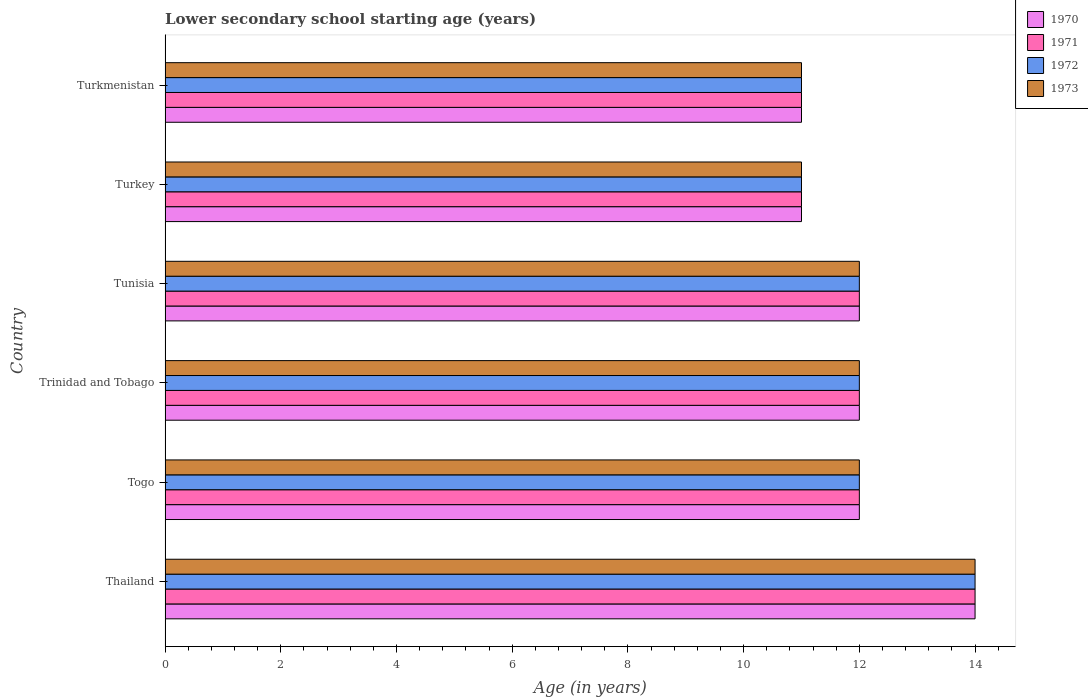How many different coloured bars are there?
Your answer should be compact. 4. Are the number of bars per tick equal to the number of legend labels?
Keep it short and to the point. Yes. Are the number of bars on each tick of the Y-axis equal?
Give a very brief answer. Yes. How many bars are there on the 6th tick from the top?
Give a very brief answer. 4. What is the label of the 6th group of bars from the top?
Keep it short and to the point. Thailand. In which country was the lower secondary school starting age of children in 1973 maximum?
Provide a short and direct response. Thailand. In which country was the lower secondary school starting age of children in 1972 minimum?
Your answer should be compact. Turkey. What is the average lower secondary school starting age of children in 1971 per country?
Your response must be concise. 12. What is the difference between the lower secondary school starting age of children in 1970 and lower secondary school starting age of children in 1973 in Turkey?
Provide a short and direct response. 0. In how many countries, is the lower secondary school starting age of children in 1970 greater than 8.4 years?
Provide a succinct answer. 6. What is the ratio of the lower secondary school starting age of children in 1973 in Thailand to that in Trinidad and Tobago?
Give a very brief answer. 1.17. What is the difference between the highest and the lowest lower secondary school starting age of children in 1970?
Keep it short and to the point. 3. Is the sum of the lower secondary school starting age of children in 1972 in Trinidad and Tobago and Tunisia greater than the maximum lower secondary school starting age of children in 1971 across all countries?
Give a very brief answer. Yes. Is it the case that in every country, the sum of the lower secondary school starting age of children in 1972 and lower secondary school starting age of children in 1970 is greater than the sum of lower secondary school starting age of children in 1971 and lower secondary school starting age of children in 1973?
Offer a very short reply. No. How many countries are there in the graph?
Make the answer very short. 6. Are the values on the major ticks of X-axis written in scientific E-notation?
Give a very brief answer. No. Where does the legend appear in the graph?
Give a very brief answer. Top right. What is the title of the graph?
Your answer should be compact. Lower secondary school starting age (years). Does "1987" appear as one of the legend labels in the graph?
Offer a very short reply. No. What is the label or title of the X-axis?
Make the answer very short. Age (in years). What is the label or title of the Y-axis?
Provide a short and direct response. Country. What is the Age (in years) of 1971 in Thailand?
Provide a short and direct response. 14. What is the Age (in years) in 1972 in Thailand?
Your response must be concise. 14. What is the Age (in years) in 1971 in Togo?
Provide a succinct answer. 12. What is the Age (in years) in 1971 in Trinidad and Tobago?
Provide a short and direct response. 12. What is the Age (in years) of 1972 in Trinidad and Tobago?
Keep it short and to the point. 12. What is the Age (in years) of 1970 in Tunisia?
Your answer should be compact. 12. What is the Age (in years) in 1971 in Tunisia?
Keep it short and to the point. 12. What is the Age (in years) of 1972 in Tunisia?
Make the answer very short. 12. What is the Age (in years) in 1971 in Turkey?
Ensure brevity in your answer.  11. What is the Age (in years) of 1972 in Turkey?
Give a very brief answer. 11. What is the Age (in years) in 1973 in Turkey?
Give a very brief answer. 11. What is the Age (in years) of 1970 in Turkmenistan?
Keep it short and to the point. 11. What is the Age (in years) of 1971 in Turkmenistan?
Your answer should be very brief. 11. What is the Age (in years) of 1973 in Turkmenistan?
Your answer should be very brief. 11. Across all countries, what is the maximum Age (in years) in 1970?
Make the answer very short. 14. Across all countries, what is the maximum Age (in years) in 1972?
Give a very brief answer. 14. Across all countries, what is the minimum Age (in years) of 1970?
Provide a succinct answer. 11. Across all countries, what is the minimum Age (in years) in 1971?
Make the answer very short. 11. Across all countries, what is the minimum Age (in years) in 1972?
Give a very brief answer. 11. Across all countries, what is the minimum Age (in years) of 1973?
Offer a terse response. 11. What is the total Age (in years) of 1970 in the graph?
Provide a short and direct response. 72. What is the total Age (in years) in 1973 in the graph?
Provide a succinct answer. 72. What is the difference between the Age (in years) of 1970 in Thailand and that in Togo?
Your response must be concise. 2. What is the difference between the Age (in years) in 1971 in Thailand and that in Togo?
Provide a short and direct response. 2. What is the difference between the Age (in years) in 1971 in Thailand and that in Tunisia?
Ensure brevity in your answer.  2. What is the difference between the Age (in years) of 1972 in Thailand and that in Tunisia?
Offer a terse response. 2. What is the difference between the Age (in years) of 1970 in Thailand and that in Turkey?
Keep it short and to the point. 3. What is the difference between the Age (in years) of 1972 in Thailand and that in Turkey?
Provide a short and direct response. 3. What is the difference between the Age (in years) in 1970 in Thailand and that in Turkmenistan?
Provide a succinct answer. 3. What is the difference between the Age (in years) in 1972 in Thailand and that in Turkmenistan?
Your answer should be compact. 3. What is the difference between the Age (in years) of 1970 in Togo and that in Tunisia?
Offer a very short reply. 0. What is the difference between the Age (in years) of 1971 in Togo and that in Tunisia?
Your answer should be very brief. 0. What is the difference between the Age (in years) of 1972 in Togo and that in Turkey?
Keep it short and to the point. 1. What is the difference between the Age (in years) of 1973 in Togo and that in Turkey?
Offer a very short reply. 1. What is the difference between the Age (in years) of 1972 in Togo and that in Turkmenistan?
Your answer should be compact. 1. What is the difference between the Age (in years) of 1970 in Trinidad and Tobago and that in Tunisia?
Your answer should be very brief. 0. What is the difference between the Age (in years) of 1971 in Trinidad and Tobago and that in Tunisia?
Ensure brevity in your answer.  0. What is the difference between the Age (in years) in 1973 in Trinidad and Tobago and that in Tunisia?
Ensure brevity in your answer.  0. What is the difference between the Age (in years) of 1972 in Trinidad and Tobago and that in Turkey?
Keep it short and to the point. 1. What is the difference between the Age (in years) of 1973 in Trinidad and Tobago and that in Turkey?
Make the answer very short. 1. What is the difference between the Age (in years) of 1970 in Trinidad and Tobago and that in Turkmenistan?
Provide a succinct answer. 1. What is the difference between the Age (in years) in 1973 in Trinidad and Tobago and that in Turkmenistan?
Keep it short and to the point. 1. What is the difference between the Age (in years) in 1970 in Tunisia and that in Turkey?
Offer a terse response. 1. What is the difference between the Age (in years) of 1972 in Tunisia and that in Turkey?
Give a very brief answer. 1. What is the difference between the Age (in years) of 1971 in Tunisia and that in Turkmenistan?
Your answer should be very brief. 1. What is the difference between the Age (in years) in 1973 in Tunisia and that in Turkmenistan?
Keep it short and to the point. 1. What is the difference between the Age (in years) in 1970 in Turkey and that in Turkmenistan?
Your answer should be very brief. 0. What is the difference between the Age (in years) in 1972 in Turkey and that in Turkmenistan?
Your answer should be compact. 0. What is the difference between the Age (in years) in 1971 in Thailand and the Age (in years) in 1972 in Togo?
Make the answer very short. 2. What is the difference between the Age (in years) of 1971 in Thailand and the Age (in years) of 1973 in Togo?
Give a very brief answer. 2. What is the difference between the Age (in years) in 1971 in Thailand and the Age (in years) in 1973 in Trinidad and Tobago?
Offer a very short reply. 2. What is the difference between the Age (in years) of 1970 in Thailand and the Age (in years) of 1972 in Tunisia?
Provide a short and direct response. 2. What is the difference between the Age (in years) in 1971 in Thailand and the Age (in years) in 1973 in Tunisia?
Your answer should be very brief. 2. What is the difference between the Age (in years) of 1972 in Thailand and the Age (in years) of 1973 in Tunisia?
Provide a short and direct response. 2. What is the difference between the Age (in years) in 1970 in Thailand and the Age (in years) in 1972 in Turkey?
Ensure brevity in your answer.  3. What is the difference between the Age (in years) of 1970 in Thailand and the Age (in years) of 1973 in Turkey?
Give a very brief answer. 3. What is the difference between the Age (in years) of 1971 in Thailand and the Age (in years) of 1972 in Turkey?
Make the answer very short. 3. What is the difference between the Age (in years) of 1970 in Thailand and the Age (in years) of 1971 in Turkmenistan?
Your answer should be very brief. 3. What is the difference between the Age (in years) in 1971 in Thailand and the Age (in years) in 1972 in Turkmenistan?
Provide a succinct answer. 3. What is the difference between the Age (in years) in 1971 in Thailand and the Age (in years) in 1973 in Turkmenistan?
Provide a succinct answer. 3. What is the difference between the Age (in years) of 1972 in Thailand and the Age (in years) of 1973 in Turkmenistan?
Your answer should be compact. 3. What is the difference between the Age (in years) in 1970 in Togo and the Age (in years) in 1972 in Trinidad and Tobago?
Offer a terse response. 0. What is the difference between the Age (in years) in 1970 in Togo and the Age (in years) in 1973 in Trinidad and Tobago?
Ensure brevity in your answer.  0. What is the difference between the Age (in years) of 1971 in Togo and the Age (in years) of 1973 in Trinidad and Tobago?
Your answer should be very brief. 0. What is the difference between the Age (in years) of 1972 in Togo and the Age (in years) of 1973 in Trinidad and Tobago?
Your answer should be compact. 0. What is the difference between the Age (in years) in 1970 in Togo and the Age (in years) in 1971 in Tunisia?
Keep it short and to the point. 0. What is the difference between the Age (in years) in 1970 in Togo and the Age (in years) in 1972 in Tunisia?
Provide a succinct answer. 0. What is the difference between the Age (in years) of 1970 in Togo and the Age (in years) of 1973 in Tunisia?
Keep it short and to the point. 0. What is the difference between the Age (in years) of 1970 in Togo and the Age (in years) of 1971 in Turkey?
Provide a short and direct response. 1. What is the difference between the Age (in years) of 1970 in Togo and the Age (in years) of 1973 in Turkey?
Your answer should be compact. 1. What is the difference between the Age (in years) of 1971 in Togo and the Age (in years) of 1973 in Turkey?
Provide a short and direct response. 1. What is the difference between the Age (in years) of 1972 in Togo and the Age (in years) of 1973 in Turkey?
Make the answer very short. 1. What is the difference between the Age (in years) of 1970 in Togo and the Age (in years) of 1971 in Turkmenistan?
Ensure brevity in your answer.  1. What is the difference between the Age (in years) in 1970 in Togo and the Age (in years) in 1972 in Turkmenistan?
Offer a terse response. 1. What is the difference between the Age (in years) in 1971 in Togo and the Age (in years) in 1972 in Turkmenistan?
Ensure brevity in your answer.  1. What is the difference between the Age (in years) in 1970 in Trinidad and Tobago and the Age (in years) in 1973 in Tunisia?
Give a very brief answer. 0. What is the difference between the Age (in years) in 1970 in Trinidad and Tobago and the Age (in years) in 1972 in Turkey?
Offer a very short reply. 1. What is the difference between the Age (in years) in 1970 in Trinidad and Tobago and the Age (in years) in 1973 in Turkey?
Your answer should be compact. 1. What is the difference between the Age (in years) of 1972 in Trinidad and Tobago and the Age (in years) of 1973 in Turkey?
Keep it short and to the point. 1. What is the difference between the Age (in years) of 1970 in Trinidad and Tobago and the Age (in years) of 1973 in Turkmenistan?
Ensure brevity in your answer.  1. What is the difference between the Age (in years) of 1971 in Trinidad and Tobago and the Age (in years) of 1972 in Turkmenistan?
Offer a terse response. 1. What is the difference between the Age (in years) in 1971 in Trinidad and Tobago and the Age (in years) in 1973 in Turkmenistan?
Keep it short and to the point. 1. What is the difference between the Age (in years) in 1972 in Trinidad and Tobago and the Age (in years) in 1973 in Turkmenistan?
Give a very brief answer. 1. What is the difference between the Age (in years) in 1971 in Tunisia and the Age (in years) in 1972 in Turkey?
Make the answer very short. 1. What is the difference between the Age (in years) of 1970 in Tunisia and the Age (in years) of 1971 in Turkmenistan?
Give a very brief answer. 1. What is the difference between the Age (in years) of 1971 in Tunisia and the Age (in years) of 1972 in Turkmenistan?
Your answer should be very brief. 1. What is the difference between the Age (in years) of 1972 in Tunisia and the Age (in years) of 1973 in Turkmenistan?
Your response must be concise. 1. What is the difference between the Age (in years) in 1971 in Turkey and the Age (in years) in 1973 in Turkmenistan?
Your answer should be very brief. 0. What is the difference between the Age (in years) in 1972 in Turkey and the Age (in years) in 1973 in Turkmenistan?
Your response must be concise. 0. What is the average Age (in years) in 1972 per country?
Give a very brief answer. 12. What is the difference between the Age (in years) in 1970 and Age (in years) in 1973 in Thailand?
Offer a very short reply. 0. What is the difference between the Age (in years) in 1971 and Age (in years) in 1972 in Thailand?
Your answer should be compact. 0. What is the difference between the Age (in years) in 1972 and Age (in years) in 1973 in Thailand?
Keep it short and to the point. 0. What is the difference between the Age (in years) of 1970 and Age (in years) of 1972 in Togo?
Keep it short and to the point. 0. What is the difference between the Age (in years) in 1970 and Age (in years) in 1973 in Togo?
Make the answer very short. 0. What is the difference between the Age (in years) in 1972 and Age (in years) in 1973 in Togo?
Offer a terse response. 0. What is the difference between the Age (in years) of 1970 and Age (in years) of 1971 in Trinidad and Tobago?
Make the answer very short. 0. What is the difference between the Age (in years) of 1970 and Age (in years) of 1972 in Trinidad and Tobago?
Your response must be concise. 0. What is the difference between the Age (in years) in 1970 and Age (in years) in 1973 in Trinidad and Tobago?
Provide a succinct answer. 0. What is the difference between the Age (in years) in 1971 and Age (in years) in 1973 in Trinidad and Tobago?
Keep it short and to the point. 0. What is the difference between the Age (in years) of 1970 and Age (in years) of 1971 in Tunisia?
Your answer should be compact. 0. What is the difference between the Age (in years) of 1970 and Age (in years) of 1972 in Tunisia?
Ensure brevity in your answer.  0. What is the difference between the Age (in years) in 1970 and Age (in years) in 1973 in Tunisia?
Keep it short and to the point. 0. What is the difference between the Age (in years) in 1970 and Age (in years) in 1972 in Turkey?
Ensure brevity in your answer.  0. What is the difference between the Age (in years) of 1971 and Age (in years) of 1973 in Turkey?
Provide a short and direct response. 0. What is the difference between the Age (in years) of 1970 and Age (in years) of 1972 in Turkmenistan?
Offer a very short reply. 0. What is the difference between the Age (in years) of 1970 and Age (in years) of 1973 in Turkmenistan?
Make the answer very short. 0. What is the difference between the Age (in years) in 1971 and Age (in years) in 1972 in Turkmenistan?
Provide a succinct answer. 0. What is the difference between the Age (in years) of 1971 and Age (in years) of 1973 in Turkmenistan?
Ensure brevity in your answer.  0. What is the ratio of the Age (in years) in 1970 in Thailand to that in Togo?
Ensure brevity in your answer.  1.17. What is the ratio of the Age (in years) in 1973 in Thailand to that in Togo?
Your response must be concise. 1.17. What is the ratio of the Age (in years) in 1973 in Thailand to that in Tunisia?
Give a very brief answer. 1.17. What is the ratio of the Age (in years) of 1970 in Thailand to that in Turkey?
Give a very brief answer. 1.27. What is the ratio of the Age (in years) in 1971 in Thailand to that in Turkey?
Keep it short and to the point. 1.27. What is the ratio of the Age (in years) in 1972 in Thailand to that in Turkey?
Provide a succinct answer. 1.27. What is the ratio of the Age (in years) of 1973 in Thailand to that in Turkey?
Ensure brevity in your answer.  1.27. What is the ratio of the Age (in years) in 1970 in Thailand to that in Turkmenistan?
Your response must be concise. 1.27. What is the ratio of the Age (in years) in 1971 in Thailand to that in Turkmenistan?
Your response must be concise. 1.27. What is the ratio of the Age (in years) of 1972 in Thailand to that in Turkmenistan?
Your response must be concise. 1.27. What is the ratio of the Age (in years) in 1973 in Thailand to that in Turkmenistan?
Provide a succinct answer. 1.27. What is the ratio of the Age (in years) in 1971 in Togo to that in Trinidad and Tobago?
Your response must be concise. 1. What is the ratio of the Age (in years) of 1970 in Togo to that in Tunisia?
Make the answer very short. 1. What is the ratio of the Age (in years) in 1972 in Togo to that in Tunisia?
Offer a terse response. 1. What is the ratio of the Age (in years) in 1973 in Togo to that in Tunisia?
Offer a very short reply. 1. What is the ratio of the Age (in years) in 1972 in Togo to that in Turkey?
Your answer should be very brief. 1.09. What is the ratio of the Age (in years) of 1973 in Togo to that in Turkey?
Keep it short and to the point. 1.09. What is the ratio of the Age (in years) in 1970 in Togo to that in Turkmenistan?
Your answer should be very brief. 1.09. What is the ratio of the Age (in years) of 1971 in Trinidad and Tobago to that in Tunisia?
Make the answer very short. 1. What is the ratio of the Age (in years) of 1972 in Trinidad and Tobago to that in Tunisia?
Offer a terse response. 1. What is the ratio of the Age (in years) of 1973 in Trinidad and Tobago to that in Tunisia?
Give a very brief answer. 1. What is the ratio of the Age (in years) of 1970 in Trinidad and Tobago to that in Turkey?
Your response must be concise. 1.09. What is the ratio of the Age (in years) in 1971 in Trinidad and Tobago to that in Turkey?
Your answer should be very brief. 1.09. What is the ratio of the Age (in years) of 1972 in Trinidad and Tobago to that in Turkey?
Keep it short and to the point. 1.09. What is the ratio of the Age (in years) of 1973 in Trinidad and Tobago to that in Turkey?
Offer a very short reply. 1.09. What is the ratio of the Age (in years) of 1972 in Trinidad and Tobago to that in Turkmenistan?
Your answer should be very brief. 1.09. What is the ratio of the Age (in years) in 1973 in Trinidad and Tobago to that in Turkmenistan?
Provide a succinct answer. 1.09. What is the ratio of the Age (in years) in 1971 in Tunisia to that in Turkey?
Provide a short and direct response. 1.09. What is the ratio of the Age (in years) of 1972 in Tunisia to that in Turkey?
Offer a terse response. 1.09. What is the ratio of the Age (in years) of 1973 in Tunisia to that in Turkey?
Your answer should be very brief. 1.09. What is the ratio of the Age (in years) in 1970 in Tunisia to that in Turkmenistan?
Provide a short and direct response. 1.09. What is the ratio of the Age (in years) in 1973 in Tunisia to that in Turkmenistan?
Your response must be concise. 1.09. What is the ratio of the Age (in years) in 1971 in Turkey to that in Turkmenistan?
Ensure brevity in your answer.  1. What is the ratio of the Age (in years) of 1973 in Turkey to that in Turkmenistan?
Provide a succinct answer. 1. What is the difference between the highest and the second highest Age (in years) in 1970?
Provide a short and direct response. 2. What is the difference between the highest and the lowest Age (in years) of 1971?
Keep it short and to the point. 3. What is the difference between the highest and the lowest Age (in years) in 1972?
Your answer should be compact. 3. 